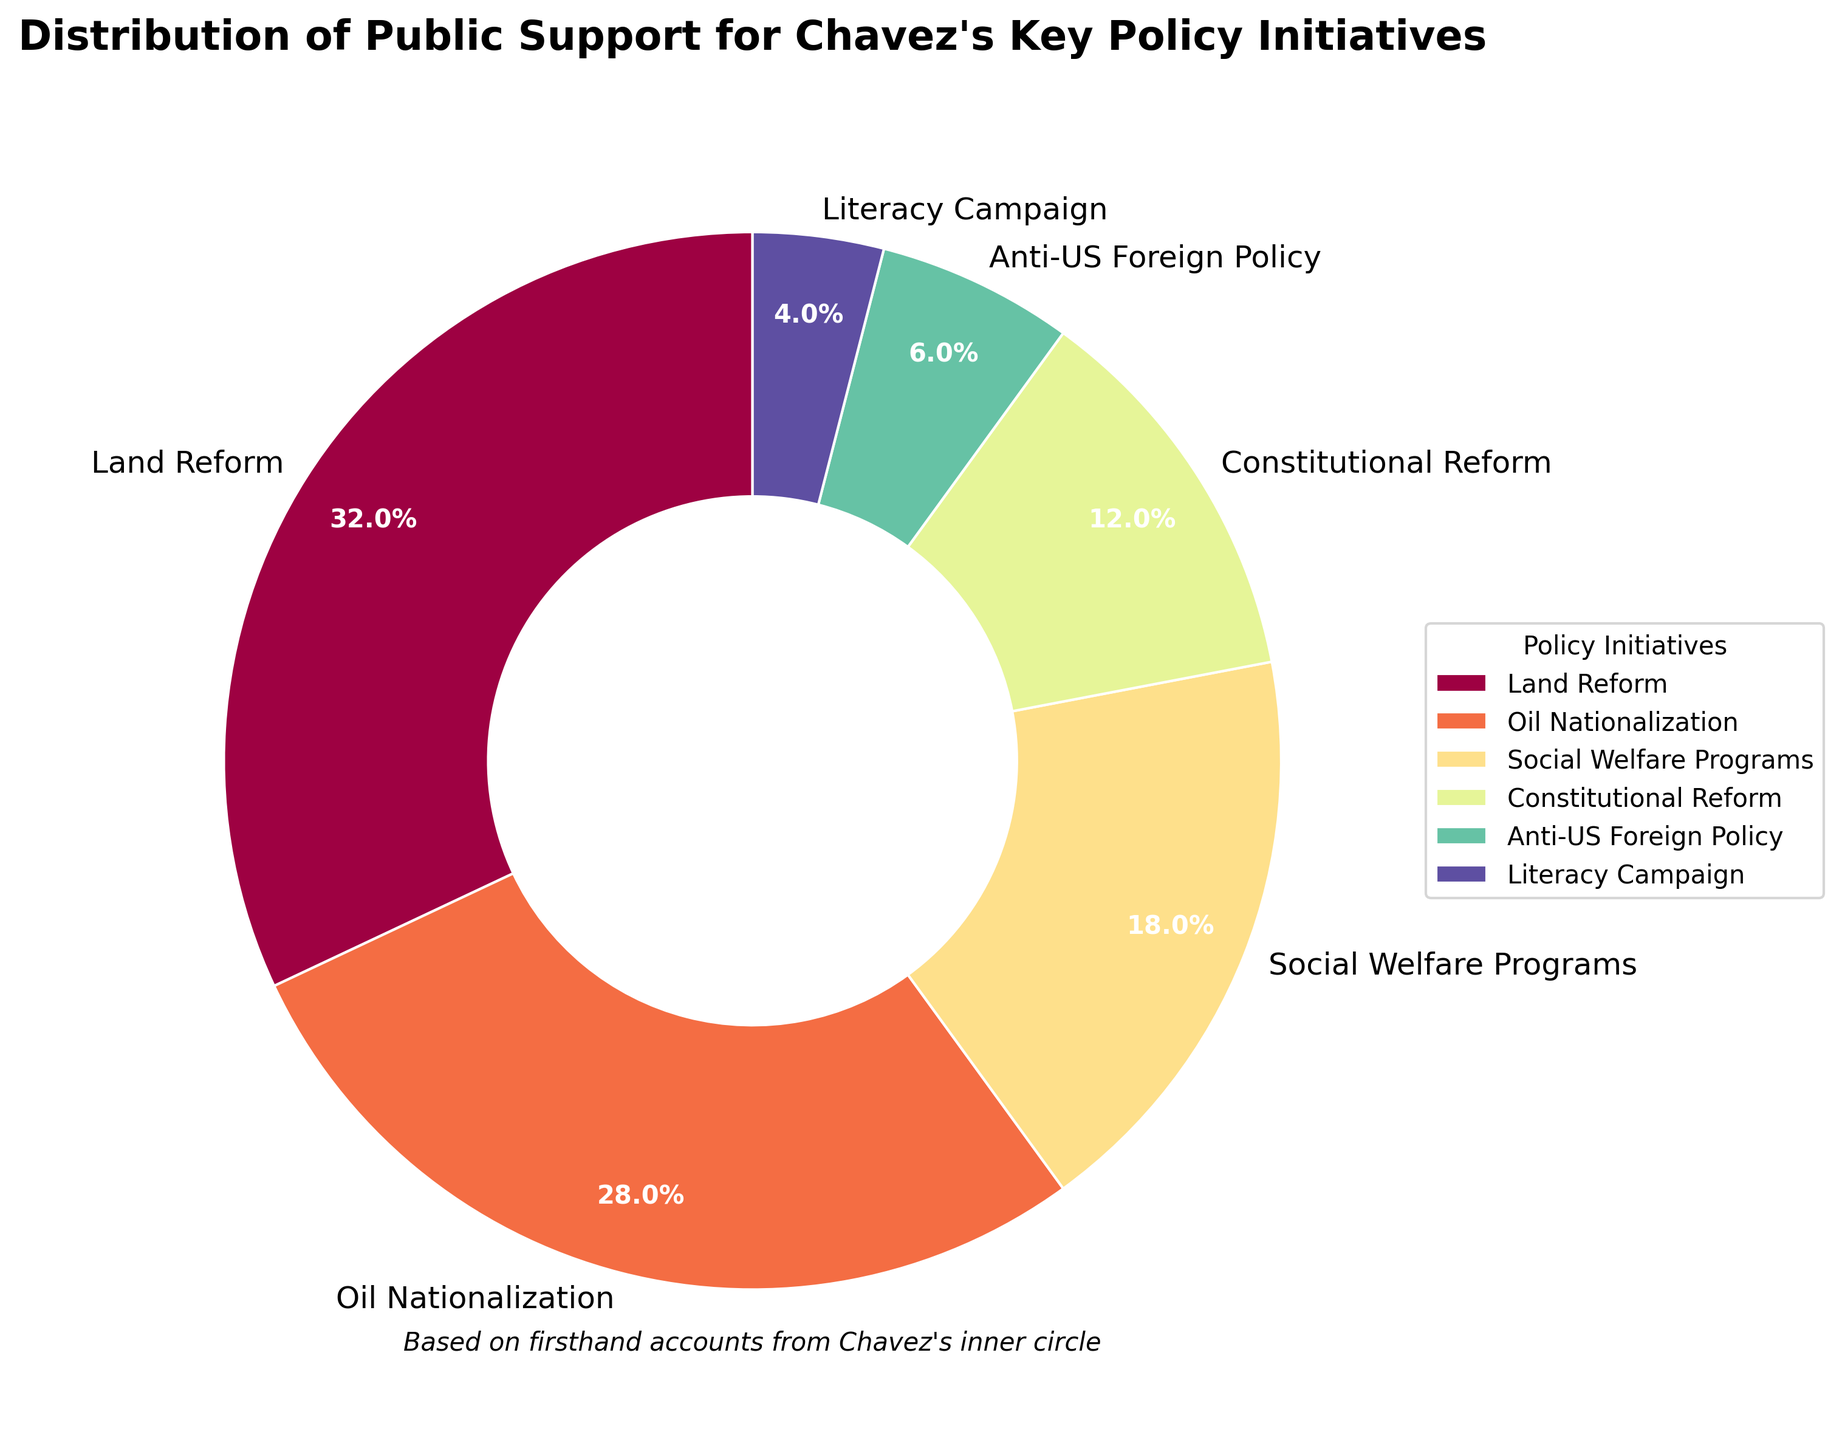What is the policy initiative with the highest support percentage? By observing the sizes of the pie slices, the largest slice corresponds to the "Land Reform" initiative.
Answer: Land Reform What is the combined support percentage for "Oil Nationalization" and "Social Welfare Programs"? From the pie chart, we see that "Oil Nationalization" has 28% support and "Social Welfare Programs" has 18% support. Adding these gives 28% + 18% = 46%.
Answer: 46% How does the support for "Constitutional Reform" compare to "Anti-US Foreign Policy"? The pie chart shows that "Constitutional Reform" has a support percentage of 12% while "Anti-US Foreign Policy" has 6%. Thus, "Constitutional Reform" has double the support compared to "Anti-US Foreign Policy".
Answer: Constitutional Reform has double the support Which policy initiative has the least support, and what is its percentage? The smallest slice on the pie chart represents the "Literacy Campaign," which has a support percentage of 4%.
Answer: Literacy Campaign with 4% What is the total support percentage for policies that have less than 10% support each? The policies with less than 10% support are "Anti-US Foreign Policy" (6%) and "Literacy Campaign" (4%). Adding these gives 6% + 4% = 10%.
Answer: 10% How does the support for "Social Welfare Programs" visually appear in comparison to "Land Reform"? The slice for "Social Welfare Programs" is visually smaller compared to the slice for "Land Reform". This indicates that "Social Welfare Programs" has less support compared to "Land Reform," specifically 18% versus 32%.
Answer: Social Welfare Programs has less support What is the difference in support percentages between the top two supported policy initiatives? The pie chart shows that "Land Reform" has 32% support and "Oil Nationalization" has 28% support. The difference is 32% - 28% = 4%.
Answer: 4% Which color represents the "Oil Nationalization" policy on the pie chart? By observing the colors assigned and matching them with the labels, "Oil Nationalization" is represented by the second color slice from the top, which appears in a certain shade (spectral colormap provides a smooth gradient, but exact color is reasoned visually).
Answer: Second shade from top 